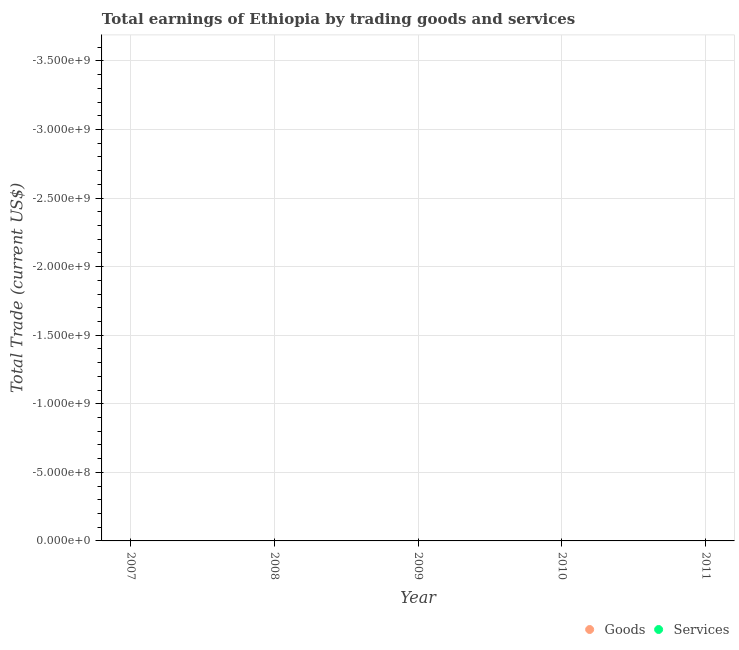How many different coloured dotlines are there?
Offer a very short reply. 0. What is the amount earned by trading goods in 2007?
Keep it short and to the point. 0. Across all years, what is the minimum amount earned by trading services?
Your answer should be compact. 0. What is the total amount earned by trading goods in the graph?
Keep it short and to the point. 0. In how many years, is the amount earned by trading services greater than -3400000000 US$?
Offer a terse response. 0. Does the amount earned by trading goods monotonically increase over the years?
Offer a very short reply. No. How many years are there in the graph?
Offer a very short reply. 5. What is the difference between two consecutive major ticks on the Y-axis?
Give a very brief answer. 5.00e+08. Does the graph contain any zero values?
Offer a very short reply. Yes. Where does the legend appear in the graph?
Ensure brevity in your answer.  Bottom right. How many legend labels are there?
Provide a succinct answer. 2. How are the legend labels stacked?
Provide a succinct answer. Horizontal. What is the title of the graph?
Your response must be concise. Total earnings of Ethiopia by trading goods and services. Does "Working only" appear as one of the legend labels in the graph?
Make the answer very short. No. What is the label or title of the X-axis?
Offer a terse response. Year. What is the label or title of the Y-axis?
Keep it short and to the point. Total Trade (current US$). What is the Total Trade (current US$) in Goods in 2008?
Your answer should be compact. 0. What is the Total Trade (current US$) of Services in 2008?
Ensure brevity in your answer.  0. What is the Total Trade (current US$) in Goods in 2009?
Your answer should be very brief. 0. What is the Total Trade (current US$) in Goods in 2010?
Offer a very short reply. 0. What is the Total Trade (current US$) of Services in 2010?
Your answer should be compact. 0. What is the Total Trade (current US$) of Services in 2011?
Your answer should be very brief. 0. What is the total Total Trade (current US$) of Services in the graph?
Make the answer very short. 0. What is the average Total Trade (current US$) in Goods per year?
Give a very brief answer. 0. 